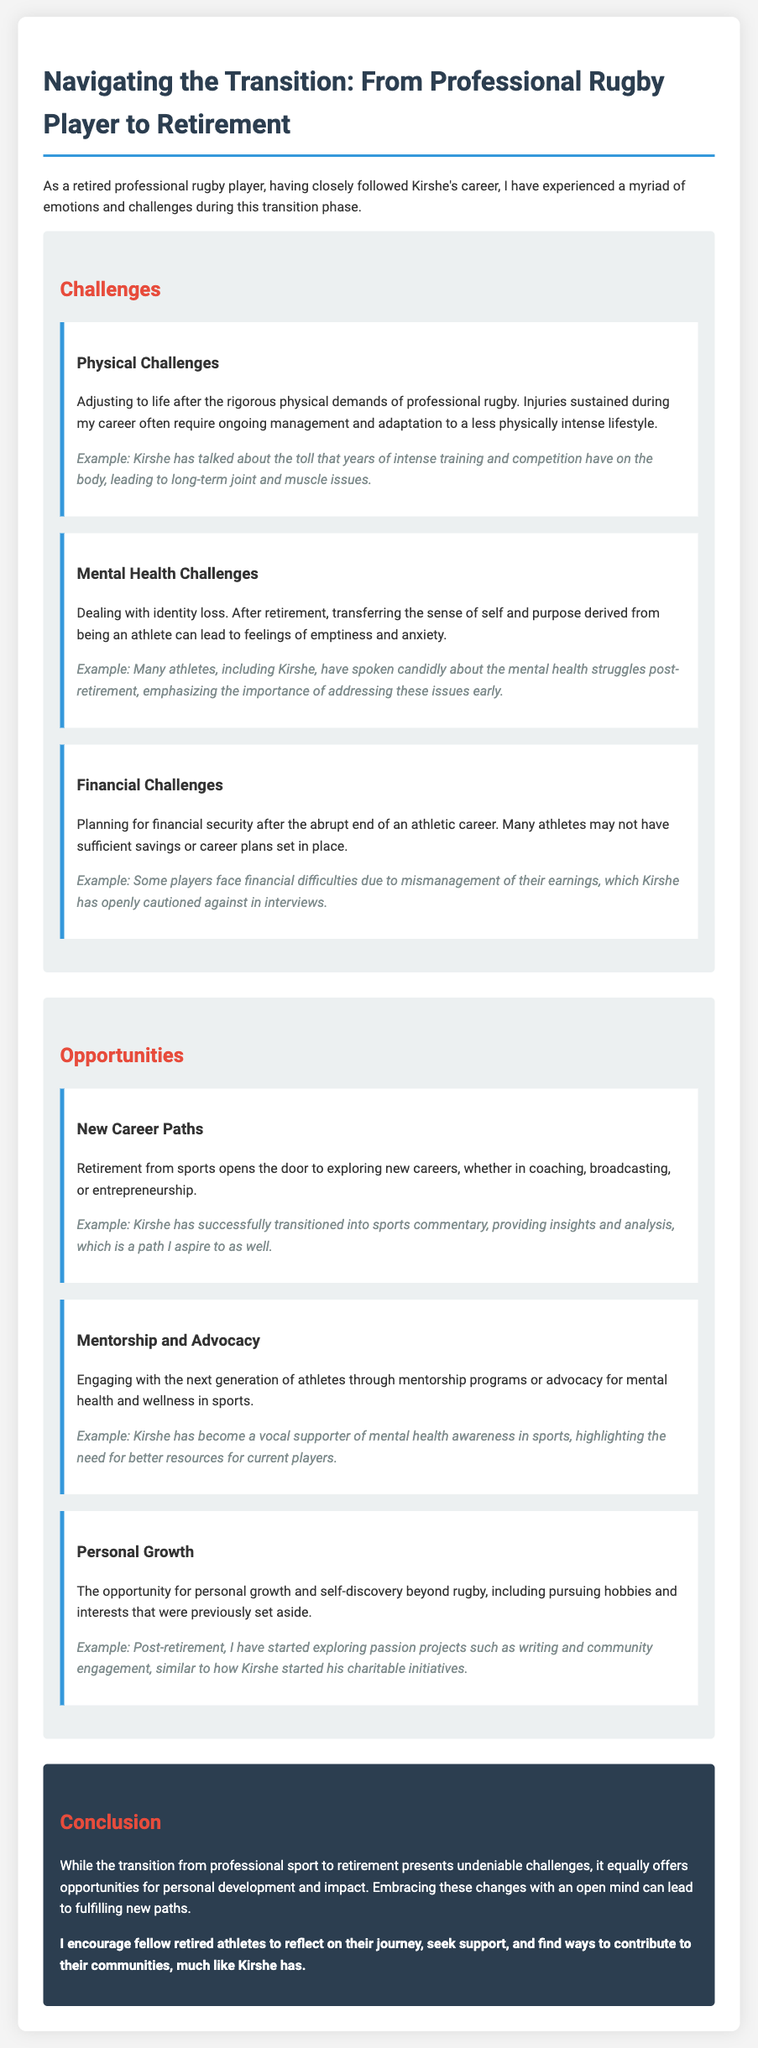What is the title of the document? The title given in the document is prominently displayed at the top.
Answer: From Rugby to Retirement: A Personal Reflection What are the three main challenges faced by retired athletes? The document explicitly lists challenges under the 'Challenges' section.
Answer: Physical, Mental Health, Financial Who is mentioned as an example for mental health challenges? The document provides specific examples to illustrate points made about challenges.
Answer: Kirshe What opportunity involves engaging with younger athletes? The opportunities section describes different pathways after retirement.
Answer: Mentorship and Advocacy Which section discusses new career paths? The document is organized into sections, each covering a different theme.
Answer: Opportunities What is the color of the conclusion section background? The style and design of the document are described, giving details about colors used.
Answer: Dark blue What type of writing has Kirshe transitioned into? The document gives examples of opportunities that former athletes have pursued post-retirement.
Answer: Sports commentary What does the author encourage retired athletes to do? The conclusion summarizes the author's key message directed at fellow athletes.
Answer: Reflect on their journey What is highlighted as a benefit of the transition to retirement? The document contrasts challenges and opportunities faced during the transition.
Answer: Personal development 